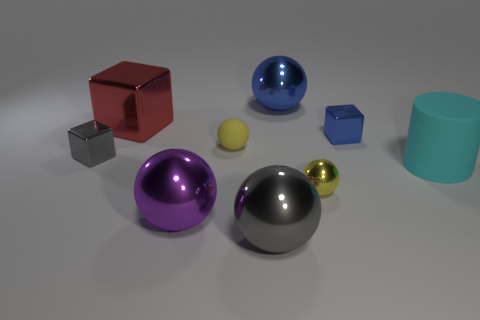There is a small ball behind the tiny yellow metal thing; does it have the same color as the small metallic ball?
Your response must be concise. Yes. How many matte objects are big red cubes or small cubes?
Your answer should be very brief. 0. What material is the tiny ball that is on the right side of the big metal ball that is behind the big red object?
Your answer should be very brief. Metal. What material is the small object that is the same color as the tiny shiny ball?
Offer a terse response. Rubber. What color is the big cube?
Provide a short and direct response. Red. Are there any rubber spheres that are behind the small metal block that is to the right of the big gray shiny thing?
Provide a succinct answer. No. What is the material of the blue sphere?
Ensure brevity in your answer.  Metal. Is the gray object in front of the big purple shiny ball made of the same material as the small block right of the purple shiny object?
Provide a short and direct response. Yes. Is there any other thing that is the same color as the large rubber cylinder?
Your response must be concise. No. There is a large object that is the same shape as the tiny blue object; what is its color?
Provide a short and direct response. Red. 